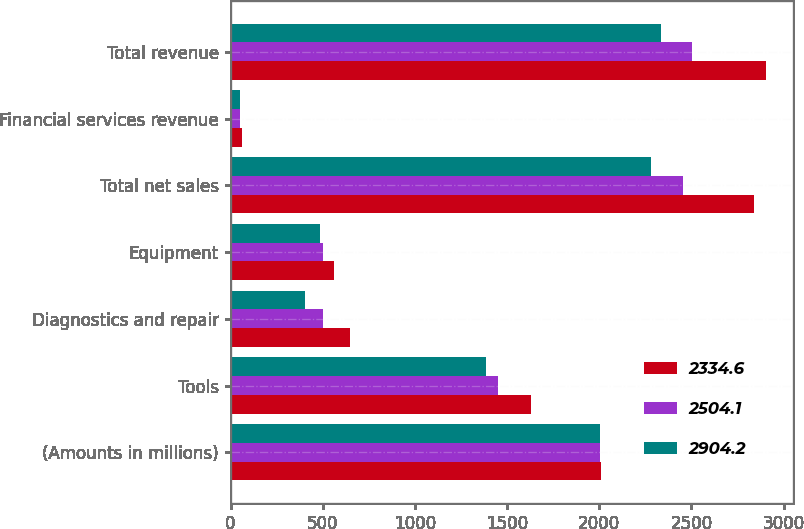Convert chart to OTSL. <chart><loc_0><loc_0><loc_500><loc_500><stacked_bar_chart><ecel><fcel>(Amounts in millions)<fcel>Tools<fcel>Diagnostics and repair<fcel>Equipment<fcel>Total net sales<fcel>Financial services revenue<fcel>Total revenue<nl><fcel>2334.6<fcel>2007<fcel>1632.2<fcel>647.6<fcel>561.4<fcel>2841.2<fcel>63<fcel>2904.2<nl><fcel>2504.1<fcel>2006<fcel>1453.1<fcel>499.5<fcel>502.5<fcel>2455.1<fcel>49<fcel>2504.1<nl><fcel>2904.2<fcel>2005<fcel>1387.3<fcel>405.8<fcel>487.9<fcel>2281<fcel>53.6<fcel>2334.6<nl></chart> 